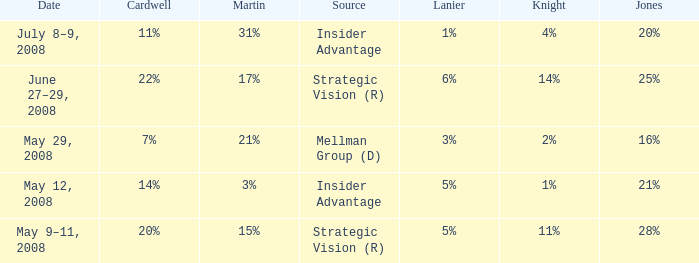What cardwell has an insider advantage and a knight of 1% 14%. 